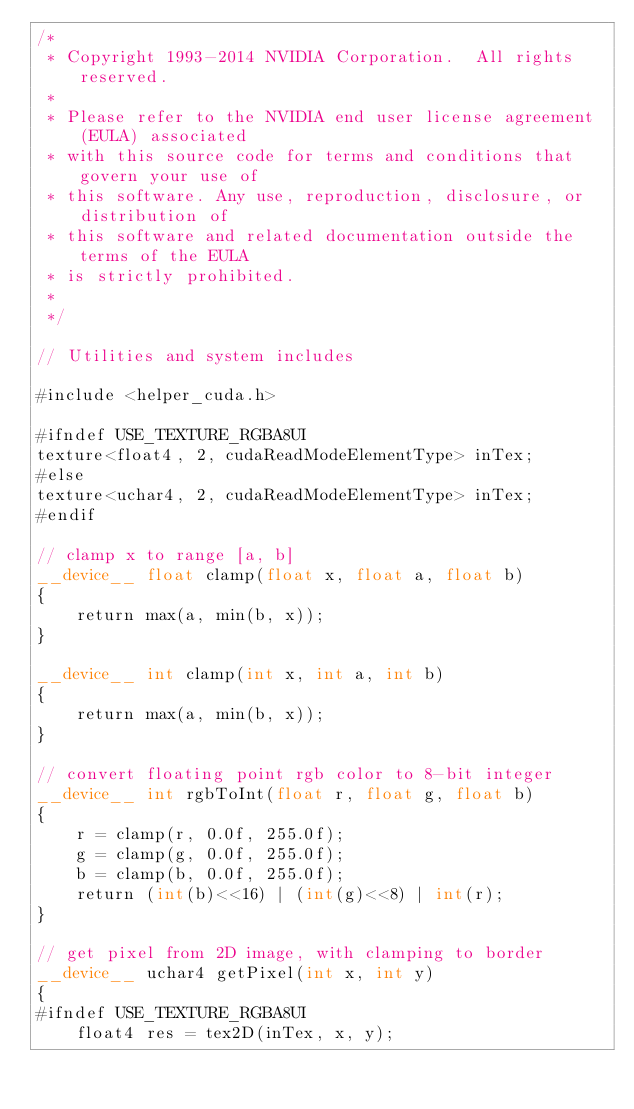Convert code to text. <code><loc_0><loc_0><loc_500><loc_500><_Cuda_>/*
 * Copyright 1993-2014 NVIDIA Corporation.  All rights reserved.
 *
 * Please refer to the NVIDIA end user license agreement (EULA) associated
 * with this source code for terms and conditions that govern your use of
 * this software. Any use, reproduction, disclosure, or distribution of
 * this software and related documentation outside the terms of the EULA
 * is strictly prohibited.
 *
 */

// Utilities and system includes

#include <helper_cuda.h>

#ifndef USE_TEXTURE_RGBA8UI
texture<float4, 2, cudaReadModeElementType> inTex;
#else
texture<uchar4, 2, cudaReadModeElementType> inTex;
#endif

// clamp x to range [a, b]
__device__ float clamp(float x, float a, float b)
{
    return max(a, min(b, x));
}

__device__ int clamp(int x, int a, int b)
{
    return max(a, min(b, x));
}

// convert floating point rgb color to 8-bit integer
__device__ int rgbToInt(float r, float g, float b)
{
    r = clamp(r, 0.0f, 255.0f);
    g = clamp(g, 0.0f, 255.0f);
    b = clamp(b, 0.0f, 255.0f);
    return (int(b)<<16) | (int(g)<<8) | int(r);
}

// get pixel from 2D image, with clamping to border
__device__ uchar4 getPixel(int x, int y)
{
#ifndef USE_TEXTURE_RGBA8UI
    float4 res = tex2D(inTex, x, y);</code> 